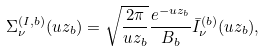Convert formula to latex. <formula><loc_0><loc_0><loc_500><loc_500>\Sigma _ { \nu } ^ { ( I , b ) } ( u z _ { b } ) = \sqrt { \frac { 2 \pi } { u z _ { b } } } \frac { e ^ { - u z _ { b } } } { B _ { b } } \bar { I } _ { \nu } ^ { ( b ) } ( u z _ { b } ) ,</formula> 